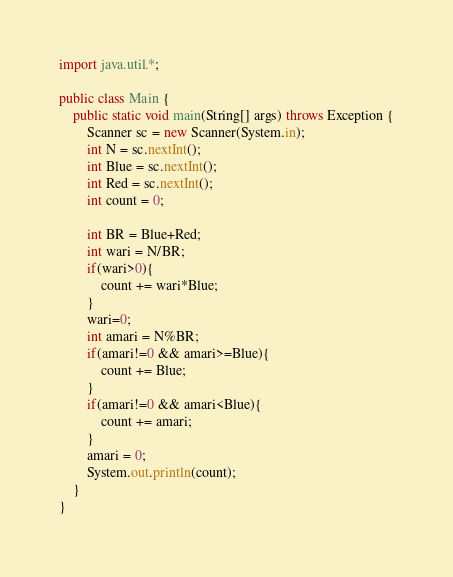Convert code to text. <code><loc_0><loc_0><loc_500><loc_500><_Java_>import java.util.*;

public class Main {
    public static void main(String[] args) throws Exception {
        Scanner sc = new Scanner(System.in);
        int N = sc.nextInt();
        int Blue = sc.nextInt();
        int Red = sc.nextInt();
        int count = 0;
        
        int BR = Blue+Red;
        int wari = N/BR;
        if(wari>0){
            count += wari*Blue;
        }
        wari=0;
        int amari = N%BR;
        if(amari!=0 && amari>=Blue){
            count += Blue;
        }
        if(amari!=0 && amari<Blue){
            count += amari;
        }
        amari = 0;
        System.out.println(count);
    }
}</code> 